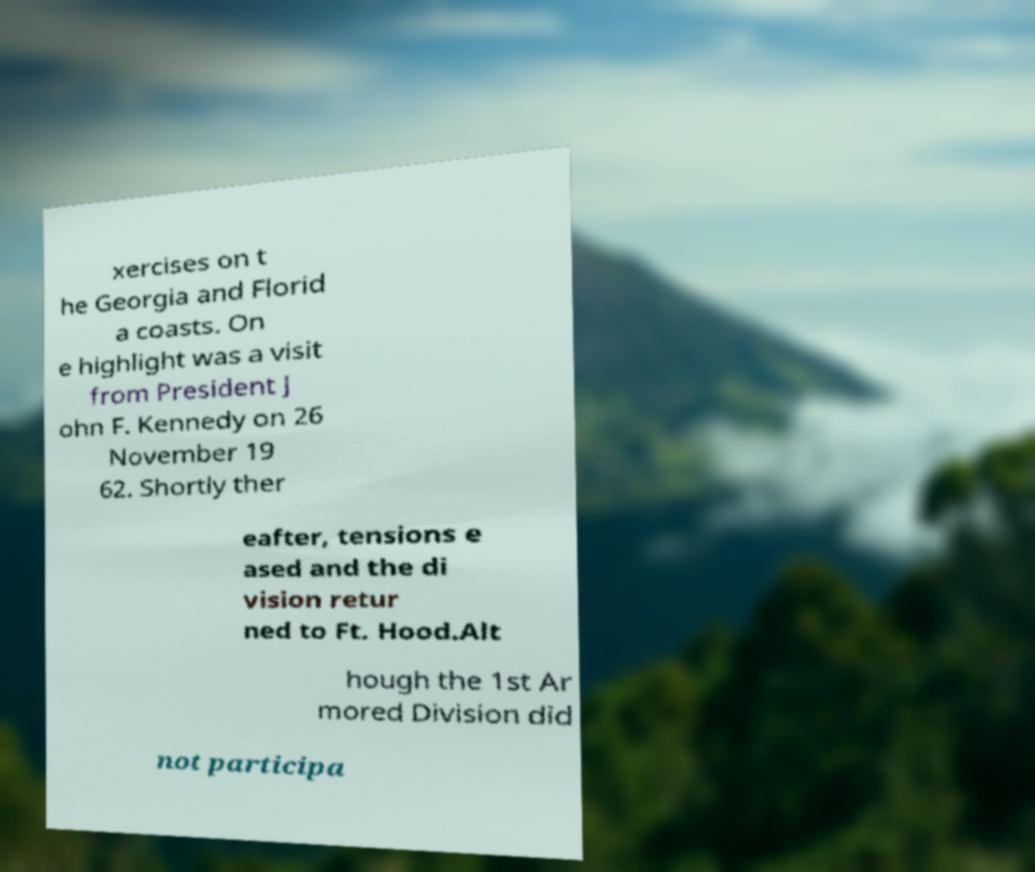For documentation purposes, I need the text within this image transcribed. Could you provide that? xercises on t he Georgia and Florid a coasts. On e highlight was a visit from President J ohn F. Kennedy on 26 November 19 62. Shortly ther eafter, tensions e ased and the di vision retur ned to Ft. Hood.Alt hough the 1st Ar mored Division did not participa 